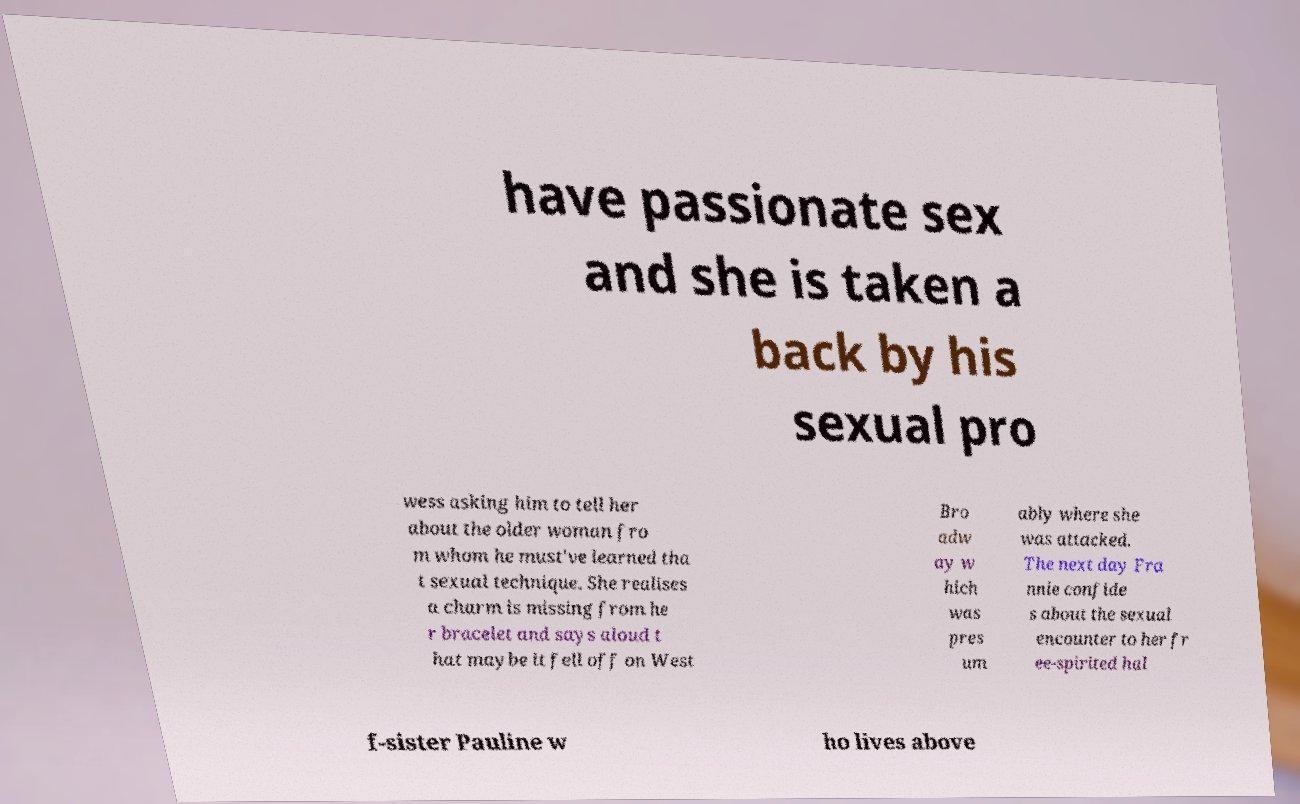Can you accurately transcribe the text from the provided image for me? have passionate sex and she is taken a back by his sexual pro wess asking him to tell her about the older woman fro m whom he must've learned tha t sexual technique. She realises a charm is missing from he r bracelet and says aloud t hat maybe it fell off on West Bro adw ay w hich was pres um ably where she was attacked. The next day Fra nnie confide s about the sexual encounter to her fr ee-spirited hal f-sister Pauline w ho lives above 